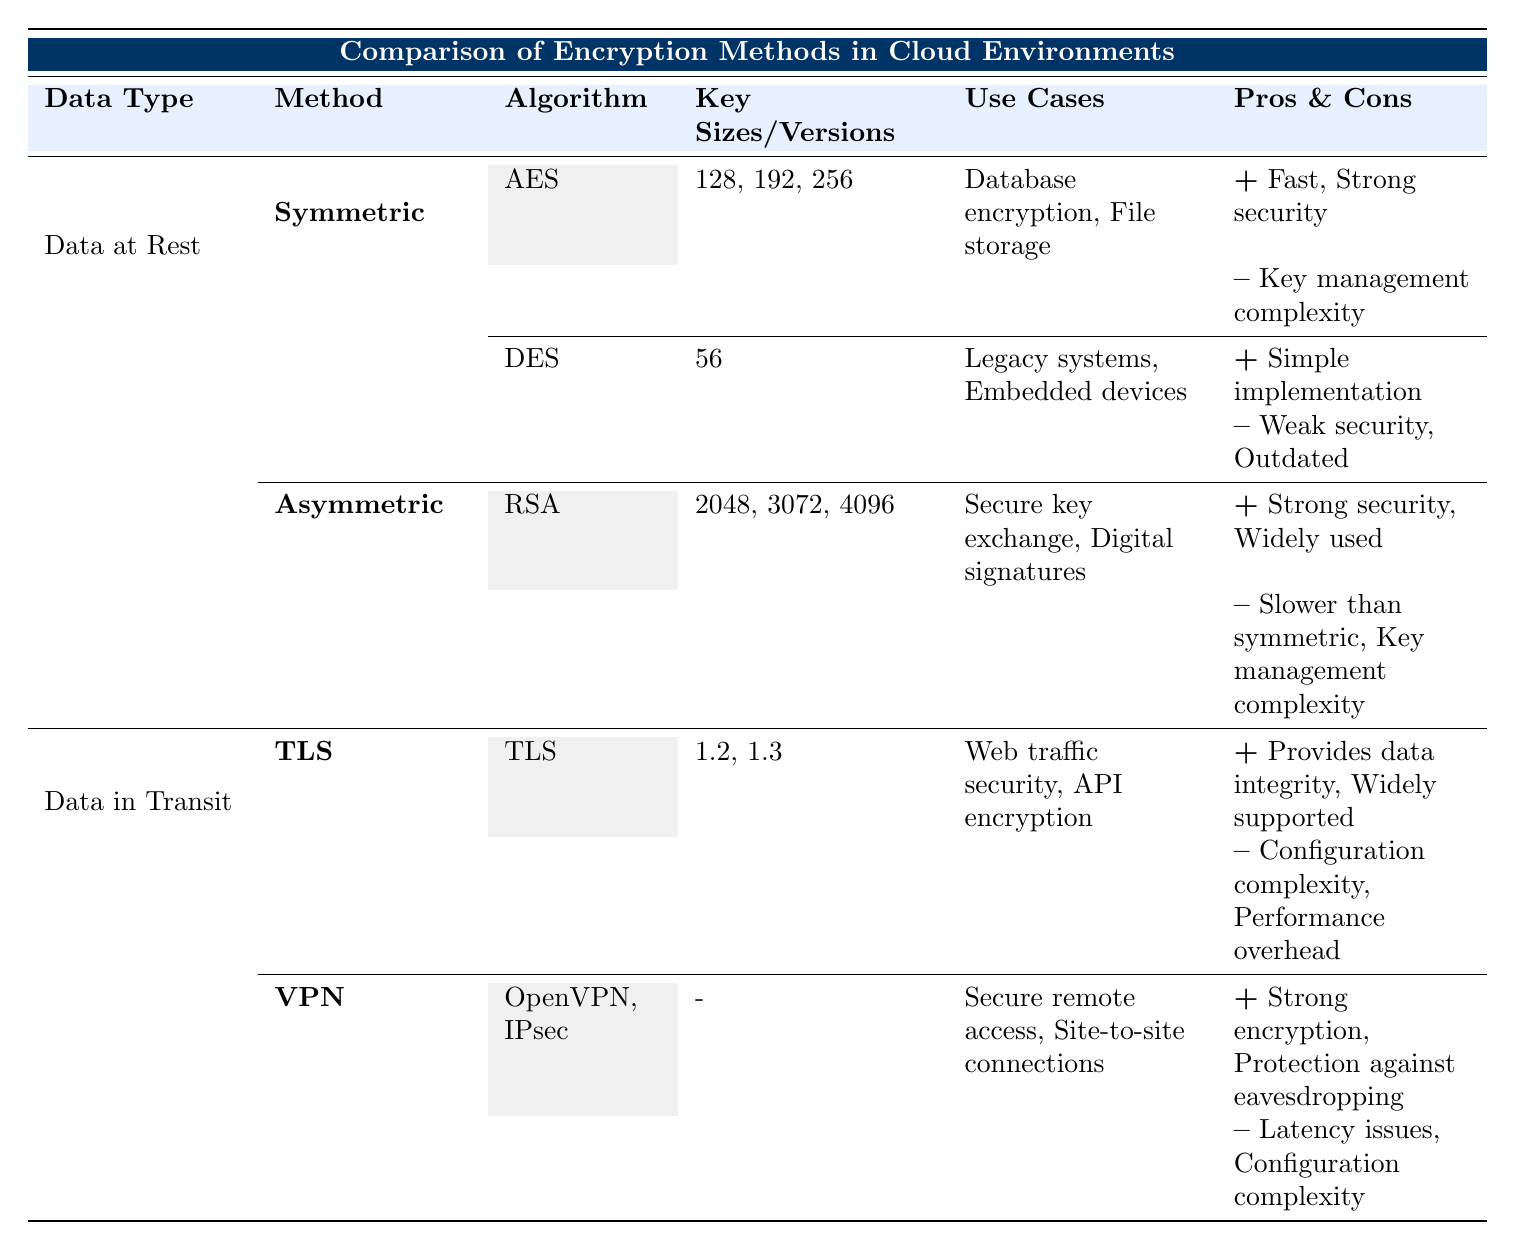What are the key sizes for AES encryption used for data at rest? The table lists the AES key sizes as 128, 192, and 256 bits. These are specifically mentioned under the "Key Sizes" column for AES in the "Symmetric" method of "Data at Rest".
Answer: 128, 192, 256 Is RSA considered faster than symmetric encryption methods? The pros and cons for RSA indicate that it is "slower than symmetric", while symmetric methods like AES are not described as having this drawback. Hence, RSA is not considered faster.
Answer: No What is a major weakness of DES encryption? The table identifies "Weak security" and "Outdated" as cons for DES under the symmetric encryption section for data at rest. This indicates that it is not a strong encryption method by modern standards.
Answer: Weak security, Outdated What methods are listed for data in transit? Under "Data in Transit", the methods listed are "TLS" and "VPN". The table explicitly shows these two categories.
Answer: TLS, VPN Which encryption method provides strong encryption and also protects against eavesdropping? The VPN method, as indicated in the table, provides "Strong encryption" and "Protection against eavesdropping" among its pros.
Answer: VPN What are the main use cases for TLS in cloud environments? The table states that TLS is used for "Web traffic security" and "API encryption", which are its specified use cases under the Data in Transit section.
Answer: Web traffic security, API encryption What is the configuration complexity associated with VPNs? The table notes that VPNs have "Configuration complexity" as one of their cons, indicating that setting up VPNs can require a detailed and potentially complicated setup process.
Answer: Configuration complexity What are the differences in key sizes between AES and RSA? AES has key sizes of 128, 192, and 256 bits, while RSA has key sizes of 2048, 3072, and 4096 bits. This makes the key sizes significantly larger for RSA compared to AES, indicating a trade-off between speed and security.
Answer: AES: 128, 192, 256; RSA: 2048, 3072, 4096 Is it true that both AES and RSA are widely used encryption methods? According to the table, both AES (under symmetric encryption) is noted for its "Strong security", and RSA has "Widely used" listed under its pros, indicating both methods share significance in encryption practices.
Answer: Yes 